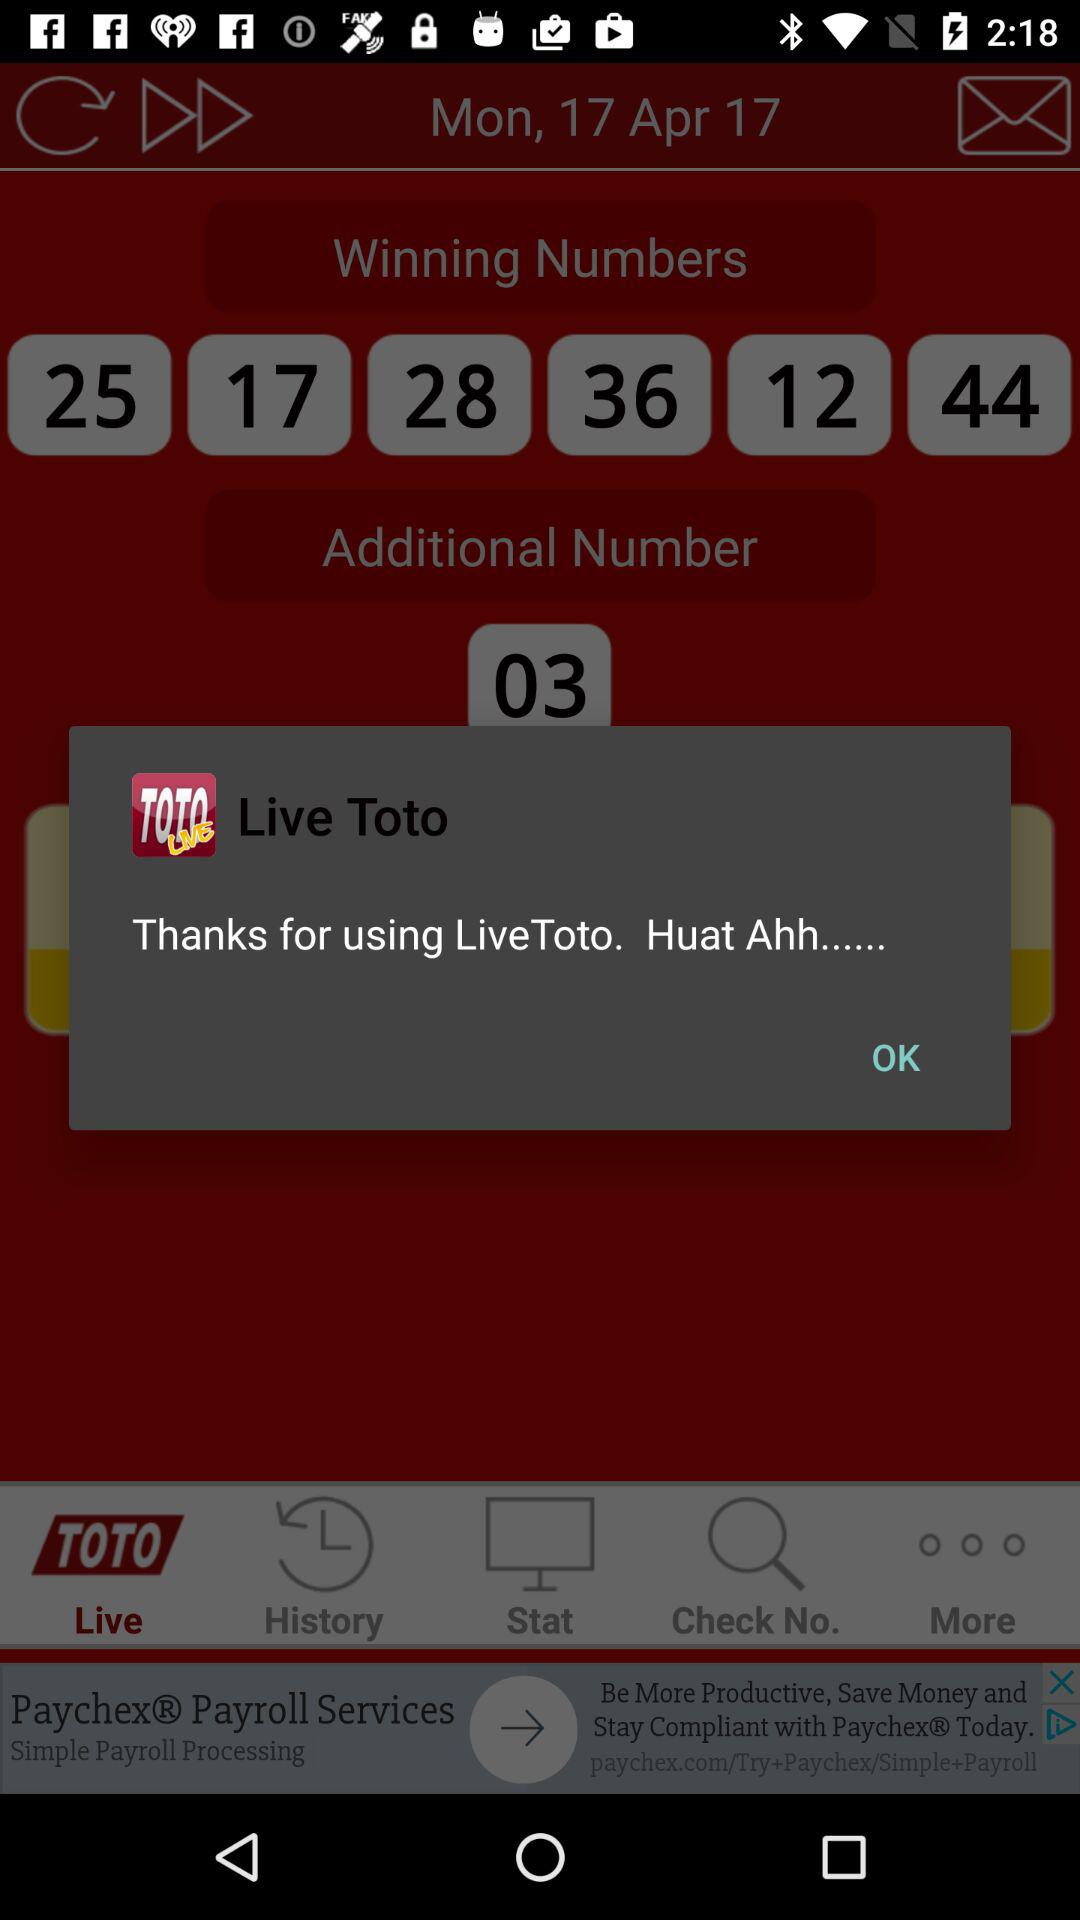What is the given date? The given date is Monday, April 17, 2017. 